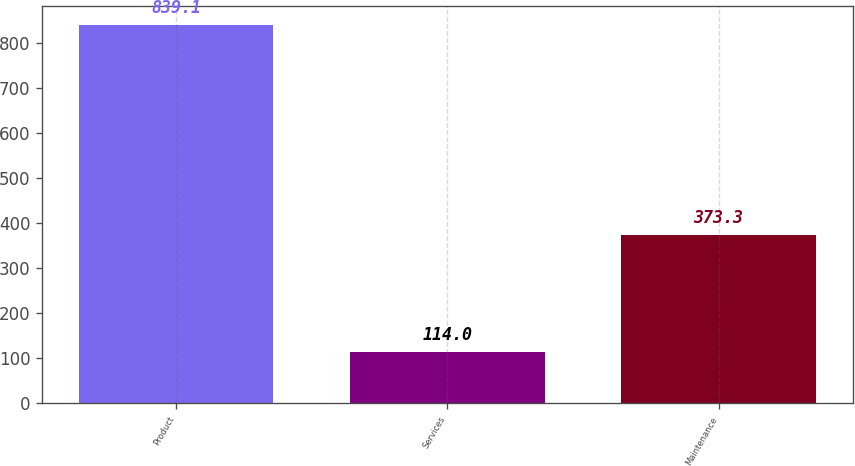<chart> <loc_0><loc_0><loc_500><loc_500><bar_chart><fcel>Product<fcel>Services<fcel>Maintenance<nl><fcel>839.1<fcel>114<fcel>373.3<nl></chart> 